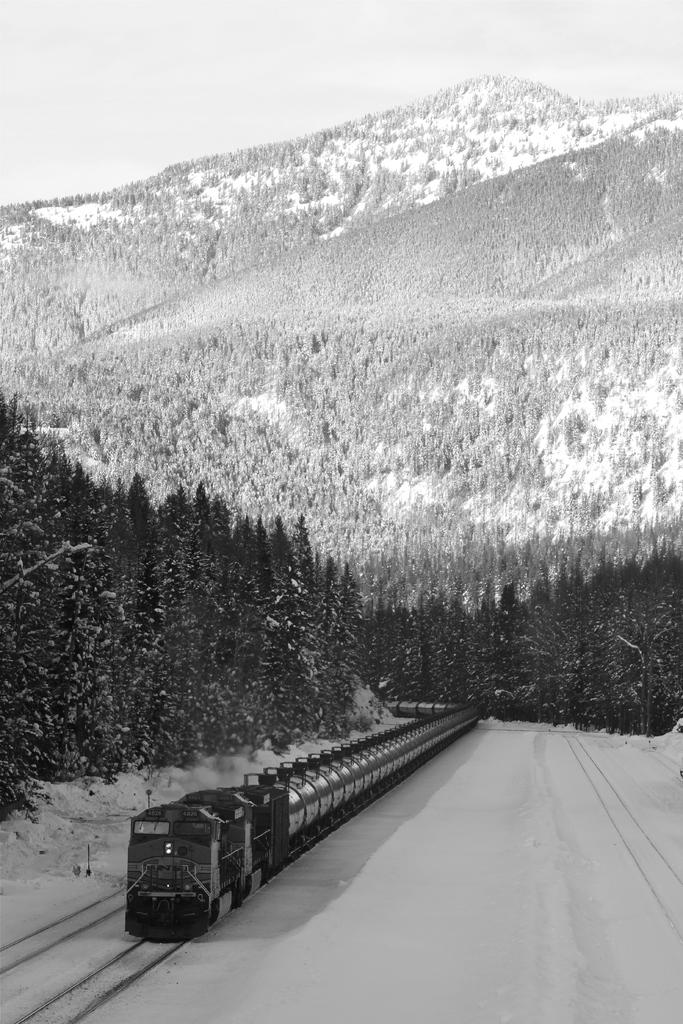What is the main subject of the black and white picture in the image? The main subject of the black and white picture in the image is a train. What is the train's position in relation to the tracks? The train is on tracks in the image. What type of natural environment is visible in the image? Trees, mountains, and snow are visible in the image, indicating a winter landscape. What part of the sky is visible in the image? The sky is visible in the image. What type of cherries can be seen growing on the train in the image? There are no cherries present in the image, and the train is not a plant that can grow fruit. Can you hear thunder in the image? There is no sound present in the image, so it is impossible to determine if thunder can be heard. 